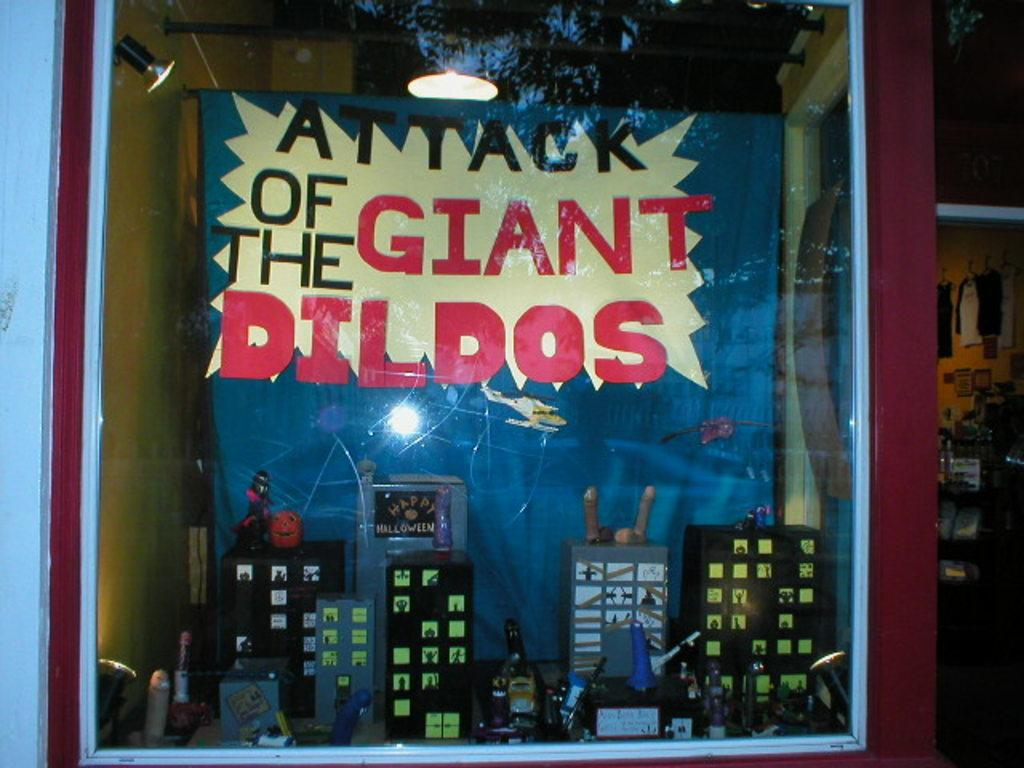<image>
Summarize the visual content of the image. a poster advertising something called attack of the giant dildos 